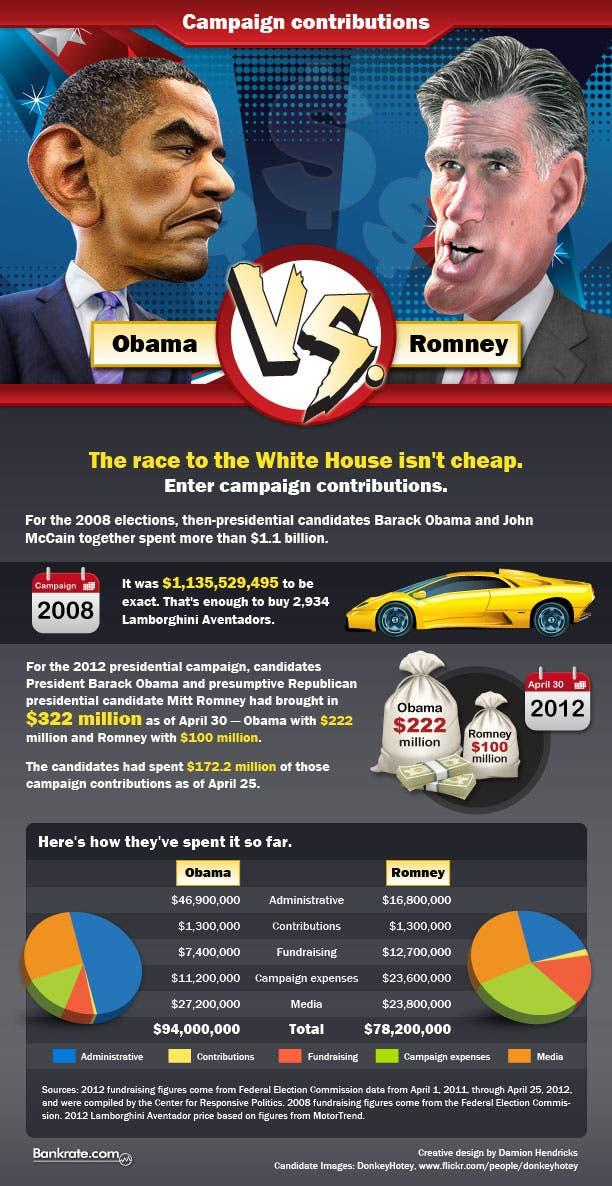Highlight a few significant elements in this photo. The color code assigned to the term "Fund Raising" is green, red, blue, and orange, with the color red being assigned to it. The total expenditure in dollars spent by both Barack Obama and Mitt Romney during the 2012 presidential election was approximately 17.22 billion. The color code given to "Media" is green, yellow, orange, and pink, with the color code for "Media" being orange. The color code given to the administrative category is blue. Mitt Romney gave greater priority to fundraising than others. 